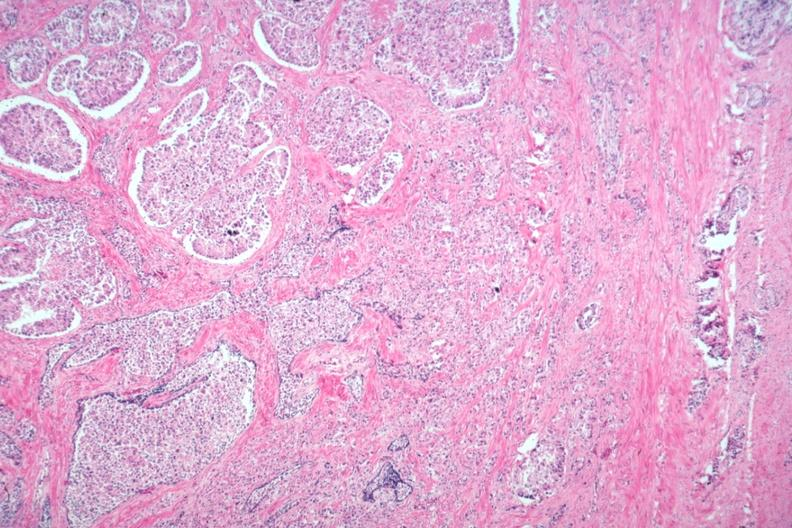s prostate present?
Answer the question using a single word or phrase. Yes 